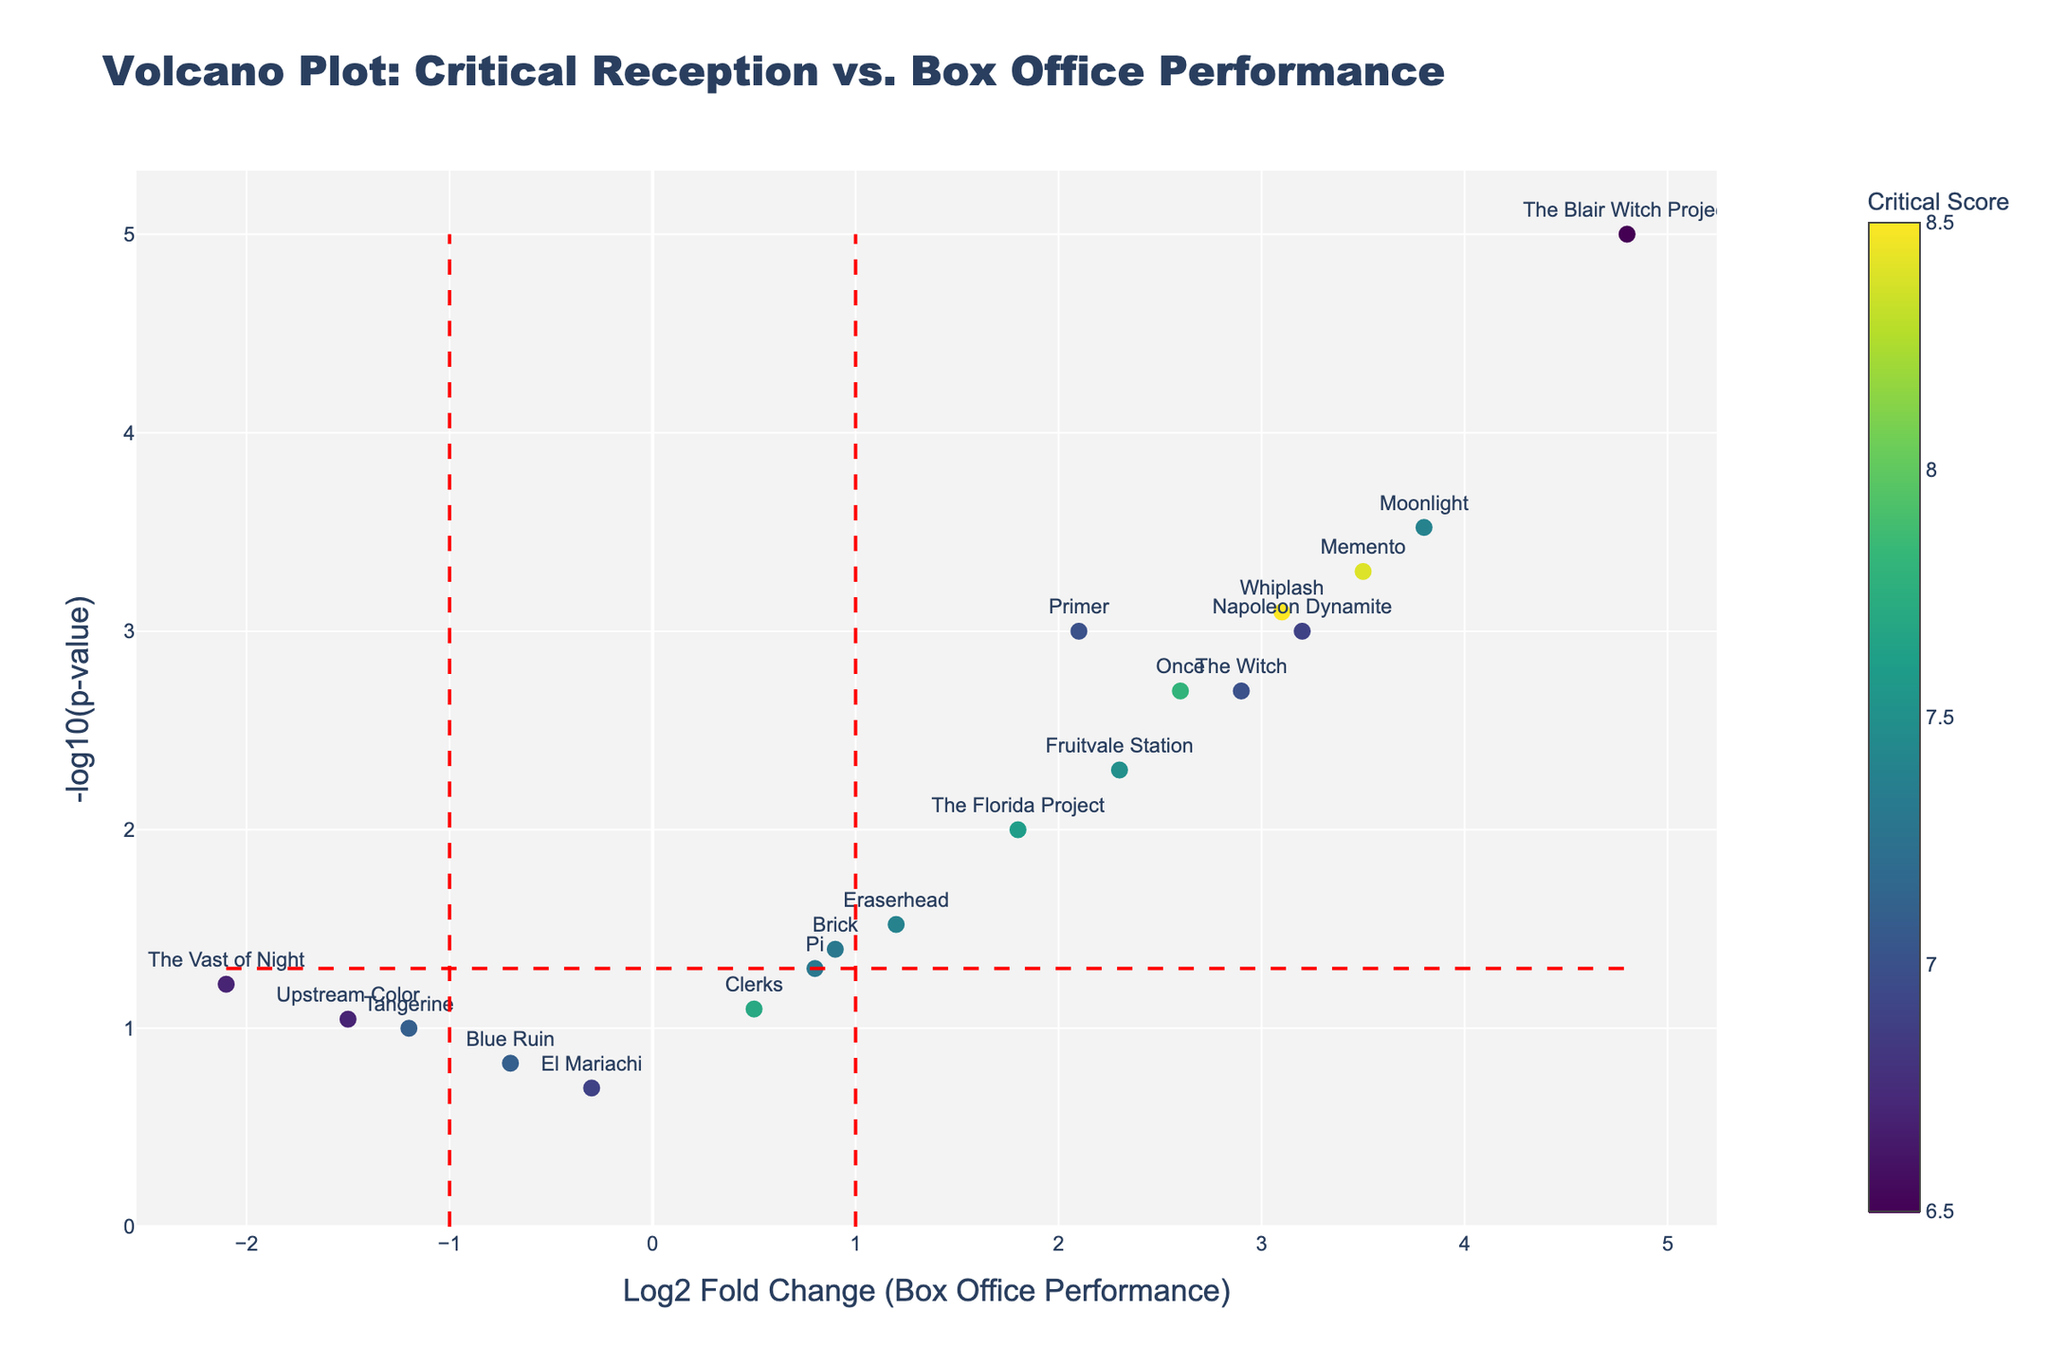What is the title of the plot? The title is displayed prominently at the top of the plot. It summarizes the plot's overall theme, which is the relationship between critical reception and box office performance for independent films.
Answer: Volcano Plot: Critical Reception vs. Box Office Performance What is represented on the x-axis? The x-axis represents the Log2 Fold Change in Box Office Performance. The axis is labeled with "Log2 Fold Change (Box Office Performance)," indicating that it measures the change in box office performance on a log base 2 scale.
Answer: Log2 Fold Change (Box Office Performance) Which film has the highest Log2 Fold Change, and what is its value? By looking along the x-axis, The Blair Witch Project stands out the most to the right, indicating the highest Log2 Fold Change. The hover text would reveal its exact value.
Answer: The Blair Witch Project, 4.8 Which film has the lowest Log2 Fold Change, and what is its value? By looking along the x-axis, The Vast of Night stands out the most to the left, indicating the lowest Log2 Fold Change. The hover text would reveal its exact value.
Answer: The Vast of Night, -2.1 Which film has the smallest p-value, and what is this value? The smallest p-value corresponds to the highest point on the y-axis due to the -log10 transformation. The Blair Witch Project is the highest point on the plot, indicating the smallest p-value.
Answer: The Blair Witch Project, 0.00001 How many films have statistically significant box office performance changes? Films with statistically significant changes have points above the horizontal red dashed line representing -log10(0.05). By counting these points, we can determine the number. Note films with log2 fold change in the extreme left or right may indicate significance due to the vertical red dashed lines representing x=-1 and x=1.
Answer: 13 Which two films have the closest Log2 Fold Change? By examining the x-axis, Upstream Color and The Vast of Night appear closest, both situated in the leftmost region. The hover text will confirm this observation.
Answer: Upstream Color and The Vast of Night Which film has the highest critical score, and what is its score? By looking at the color scale on the scatter points, Whiplash appears darkest, indicating the highest critical score. The hover text will provide the exact value.
Answer: Whiplash, 8.5 Do any films fall below both Log2 Fold Change of -1 and p-value threshold of 0.05? By examining the points in the lower left quadrant of the plot, it's clear that no films meet both criteria simultaneously (Log2 Fold Change < -1 and above the horizontal red dashed line).
Answer: No What is the range of -log10(p-value) values in the plot? The range can be determined by observing the y-axis, where the minimum and maximum -log10(p-value) values are noted. The highest point, The Blair Witch Project, and the lowest significant point (below the horizontal dashed line) provide the range.
Answer: ~0 to ~5 